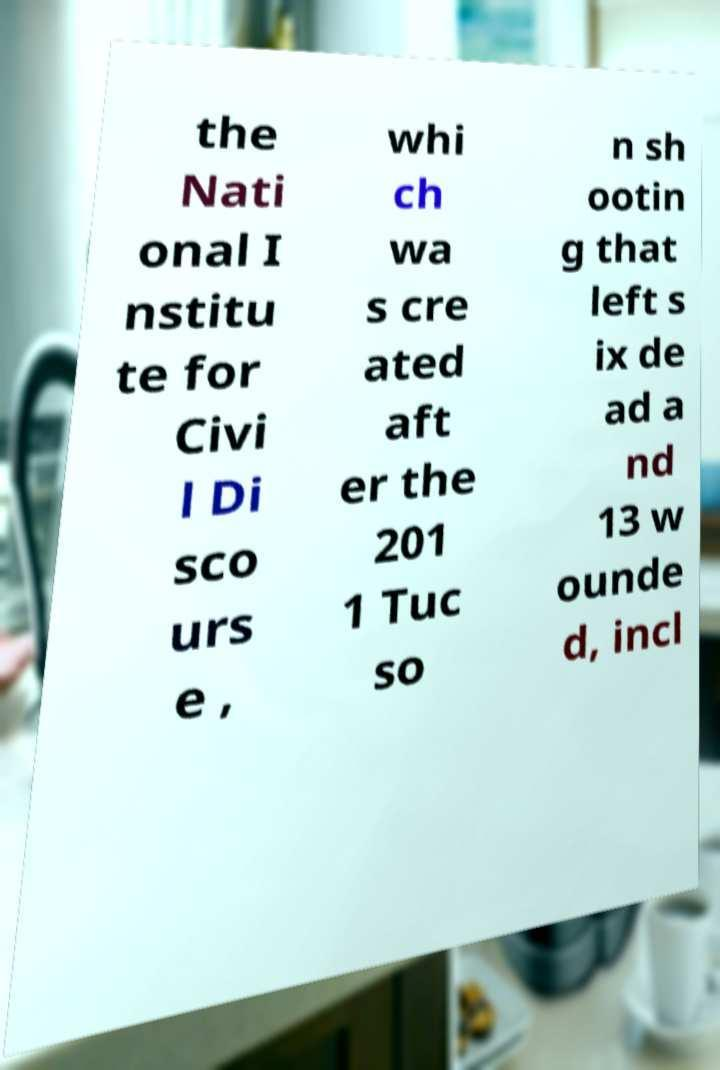I need the written content from this picture converted into text. Can you do that? the Nati onal I nstitu te for Civi l Di sco urs e , whi ch wa s cre ated aft er the 201 1 Tuc so n sh ootin g that left s ix de ad a nd 13 w ounde d, incl 